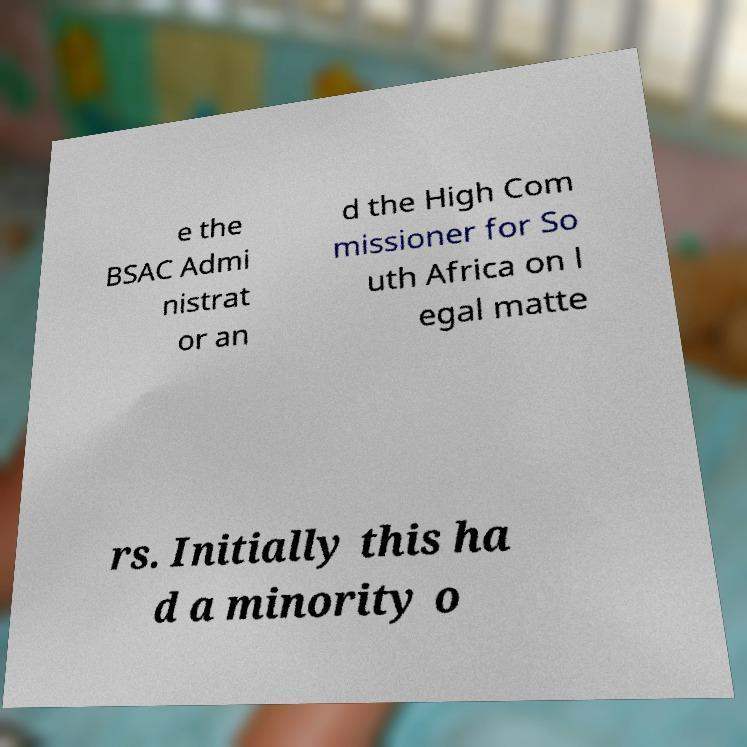I need the written content from this picture converted into text. Can you do that? e the BSAC Admi nistrat or an d the High Com missioner for So uth Africa on l egal matte rs. Initially this ha d a minority o 